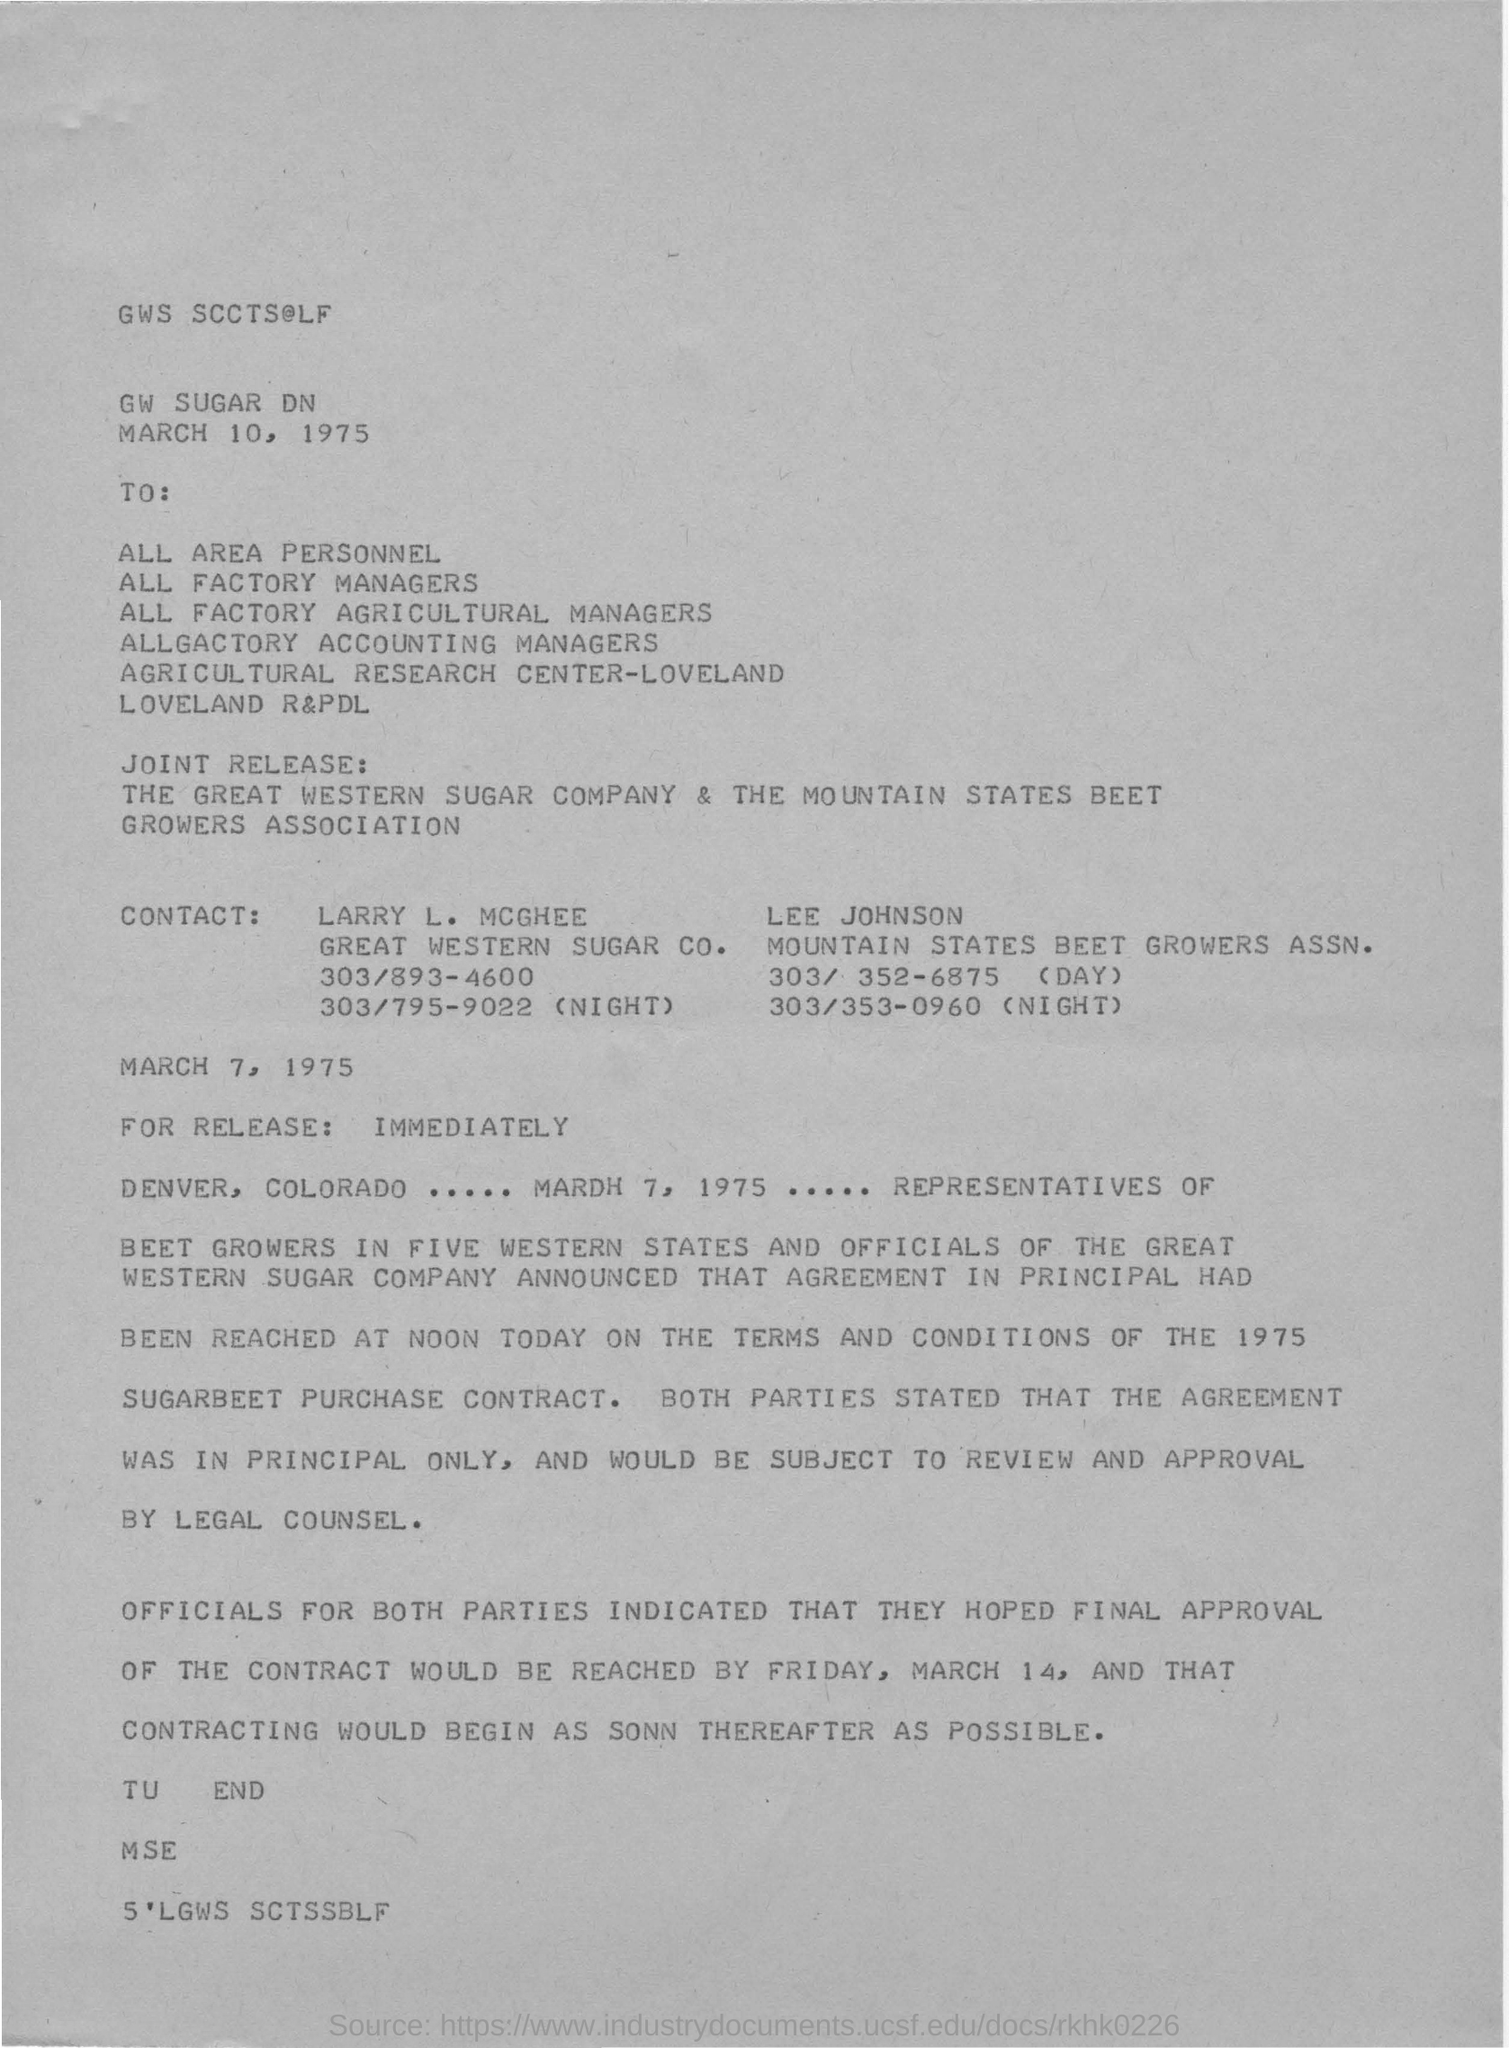Identify some key points in this picture. The final approval of the contract is expected to reach on March 14. The first CONTACT name mentioned is Larry L. McGhee. The date of the letter is March 10, 1975. 